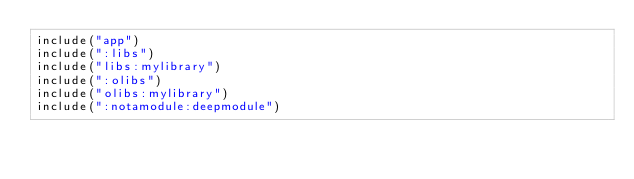<code> <loc_0><loc_0><loc_500><loc_500><_Kotlin_>include("app")
include(":libs")
include("libs:mylibrary")
include(":olibs")
include("olibs:mylibrary")
include(":notamodule:deepmodule")</code> 